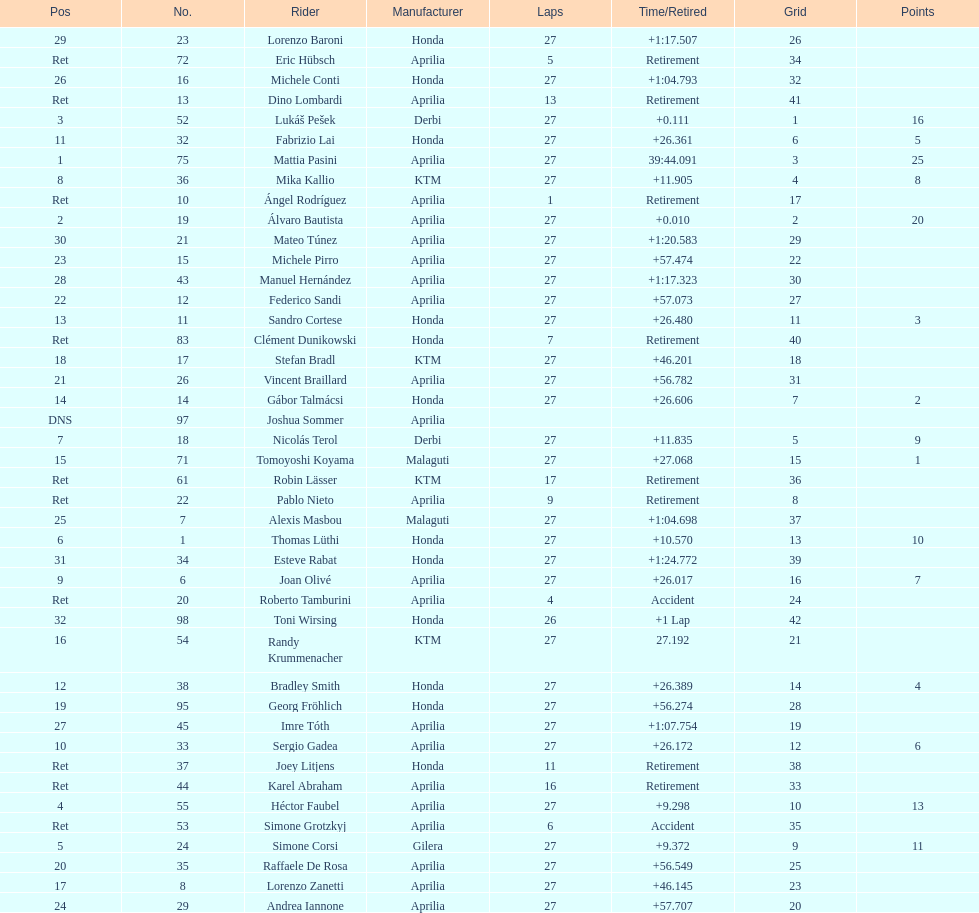How many german racers finished the race? 4. Give me the full table as a dictionary. {'header': ['Pos', 'No.', 'Rider', 'Manufacturer', 'Laps', 'Time/Retired', 'Grid', 'Points'], 'rows': [['29', '23', 'Lorenzo Baroni', 'Honda', '27', '+1:17.507', '26', ''], ['Ret', '72', 'Eric Hübsch', 'Aprilia', '5', 'Retirement', '34', ''], ['26', '16', 'Michele Conti', 'Honda', '27', '+1:04.793', '32', ''], ['Ret', '13', 'Dino Lombardi', 'Aprilia', '13', 'Retirement', '41', ''], ['3', '52', 'Lukáš Pešek', 'Derbi', '27', '+0.111', '1', '16'], ['11', '32', 'Fabrizio Lai', 'Honda', '27', '+26.361', '6', '5'], ['1', '75', 'Mattia Pasini', 'Aprilia', '27', '39:44.091', '3', '25'], ['8', '36', 'Mika Kallio', 'KTM', '27', '+11.905', '4', '8'], ['Ret', '10', 'Ángel Rodríguez', 'Aprilia', '1', 'Retirement', '17', ''], ['2', '19', 'Álvaro Bautista', 'Aprilia', '27', '+0.010', '2', '20'], ['30', '21', 'Mateo Túnez', 'Aprilia', '27', '+1:20.583', '29', ''], ['23', '15', 'Michele Pirro', 'Aprilia', '27', '+57.474', '22', ''], ['28', '43', 'Manuel Hernández', 'Aprilia', '27', '+1:17.323', '30', ''], ['22', '12', 'Federico Sandi', 'Aprilia', '27', '+57.073', '27', ''], ['13', '11', 'Sandro Cortese', 'Honda', '27', '+26.480', '11', '3'], ['Ret', '83', 'Clément Dunikowski', 'Honda', '7', 'Retirement', '40', ''], ['18', '17', 'Stefan Bradl', 'KTM', '27', '+46.201', '18', ''], ['21', '26', 'Vincent Braillard', 'Aprilia', '27', '+56.782', '31', ''], ['14', '14', 'Gábor Talmácsi', 'Honda', '27', '+26.606', '7', '2'], ['DNS', '97', 'Joshua Sommer', 'Aprilia', '', '', '', ''], ['7', '18', 'Nicolás Terol', 'Derbi', '27', '+11.835', '5', '9'], ['15', '71', 'Tomoyoshi Koyama', 'Malaguti', '27', '+27.068', '15', '1'], ['Ret', '61', 'Robin Lässer', 'KTM', '17', 'Retirement', '36', ''], ['Ret', '22', 'Pablo Nieto', 'Aprilia', '9', 'Retirement', '8', ''], ['25', '7', 'Alexis Masbou', 'Malaguti', '27', '+1:04.698', '37', ''], ['6', '1', 'Thomas Lüthi', 'Honda', '27', '+10.570', '13', '10'], ['31', '34', 'Esteve Rabat', 'Honda', '27', '+1:24.772', '39', ''], ['9', '6', 'Joan Olivé', 'Aprilia', '27', '+26.017', '16', '7'], ['Ret', '20', 'Roberto Tamburini', 'Aprilia', '4', 'Accident', '24', ''], ['32', '98', 'Toni Wirsing', 'Honda', '26', '+1 Lap', '42', ''], ['16', '54', 'Randy Krummenacher', 'KTM', '27', '27.192', '21', ''], ['12', '38', 'Bradley Smith', 'Honda', '27', '+26.389', '14', '4'], ['19', '95', 'Georg Fröhlich', 'Honda', '27', '+56.274', '28', ''], ['27', '45', 'Imre Tóth', 'Aprilia', '27', '+1:07.754', '19', ''], ['10', '33', 'Sergio Gadea', 'Aprilia', '27', '+26.172', '12', '6'], ['Ret', '37', 'Joey Litjens', 'Honda', '11', 'Retirement', '38', ''], ['Ret', '44', 'Karel Abraham', 'Aprilia', '16', 'Retirement', '33', ''], ['4', '55', 'Héctor Faubel', 'Aprilia', '27', '+9.298', '10', '13'], ['Ret', '53', 'Simone Grotzkyj', 'Aprilia', '6', 'Accident', '35', ''], ['5', '24', 'Simone Corsi', 'Gilera', '27', '+9.372', '9', '11'], ['20', '35', 'Raffaele De Rosa', 'Aprilia', '27', '+56.549', '25', ''], ['17', '8', 'Lorenzo Zanetti', 'Aprilia', '27', '+46.145', '23', ''], ['24', '29', 'Andrea Iannone', 'Aprilia', '27', '+57.707', '20', '']]} 